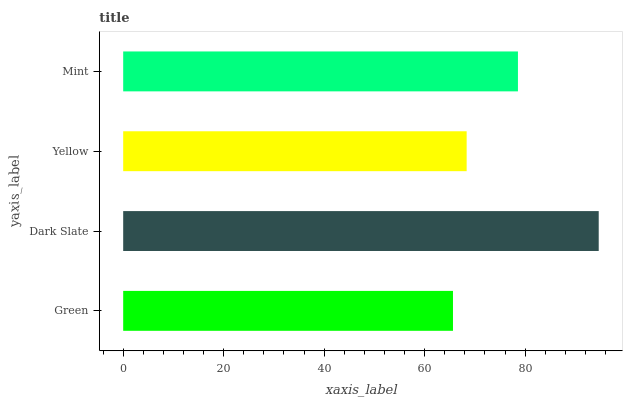Is Green the minimum?
Answer yes or no. Yes. Is Dark Slate the maximum?
Answer yes or no. Yes. Is Yellow the minimum?
Answer yes or no. No. Is Yellow the maximum?
Answer yes or no. No. Is Dark Slate greater than Yellow?
Answer yes or no. Yes. Is Yellow less than Dark Slate?
Answer yes or no. Yes. Is Yellow greater than Dark Slate?
Answer yes or no. No. Is Dark Slate less than Yellow?
Answer yes or no. No. Is Mint the high median?
Answer yes or no. Yes. Is Yellow the low median?
Answer yes or no. Yes. Is Dark Slate the high median?
Answer yes or no. No. Is Dark Slate the low median?
Answer yes or no. No. 